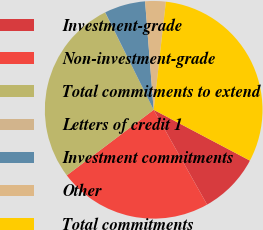<chart> <loc_0><loc_0><loc_500><loc_500><pie_chart><fcel>Investment-grade<fcel>Non-investment-grade<fcel>Total commitments to extend<fcel>Letters of credit 1<fcel>Investment commitments<fcel>Other<fcel>Total commitments<nl><fcel>9.1%<fcel>22.88%<fcel>27.92%<fcel>0.03%<fcel>6.08%<fcel>3.05%<fcel>30.94%<nl></chart> 